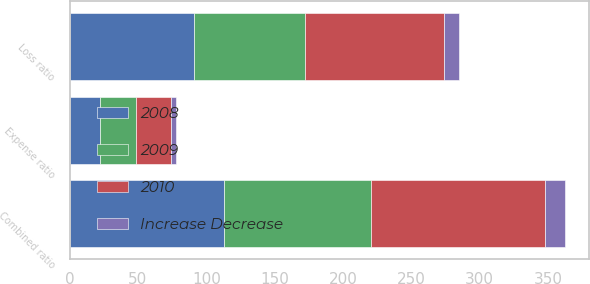Convert chart. <chart><loc_0><loc_0><loc_500><loc_500><stacked_bar_chart><ecel><fcel>Loss ratio<fcel>Expense ratio<fcel>Combined ratio<nl><fcel>2010<fcel>101.6<fcel>25.6<fcel>127.2<nl><fcel>2008<fcel>90.7<fcel>22.3<fcel>113<nl><fcel>Increase Decrease<fcel>10.9<fcel>3.3<fcel>14.2<nl><fcel>2009<fcel>81.4<fcel>26.3<fcel>107.7<nl></chart> 